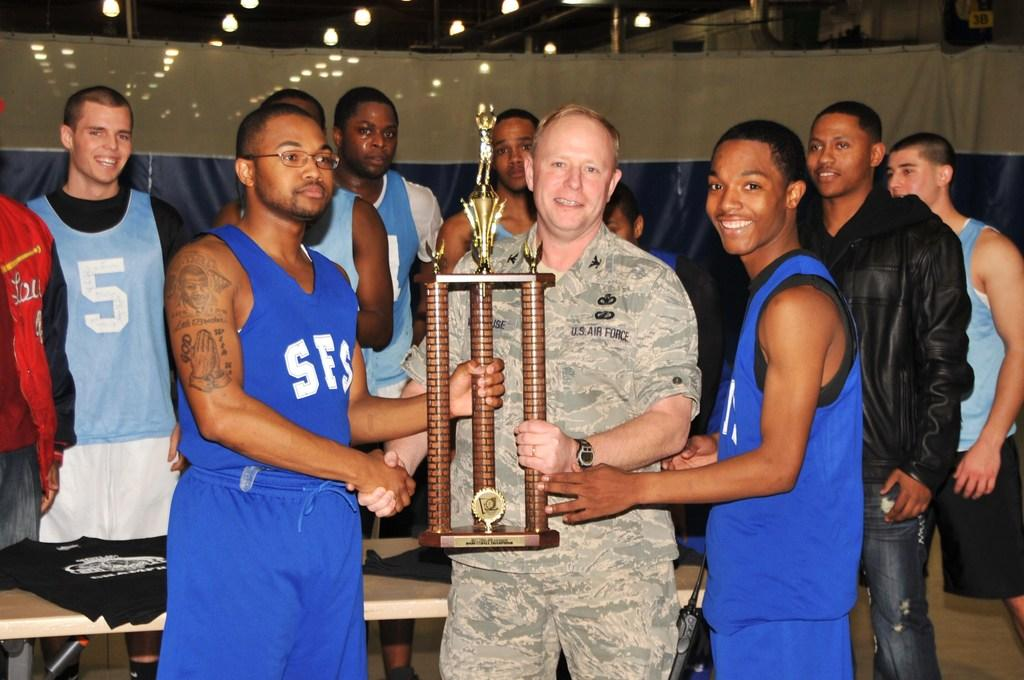<image>
Summarize the visual content of the image. a blue jersey on a player with the letter SES on it 